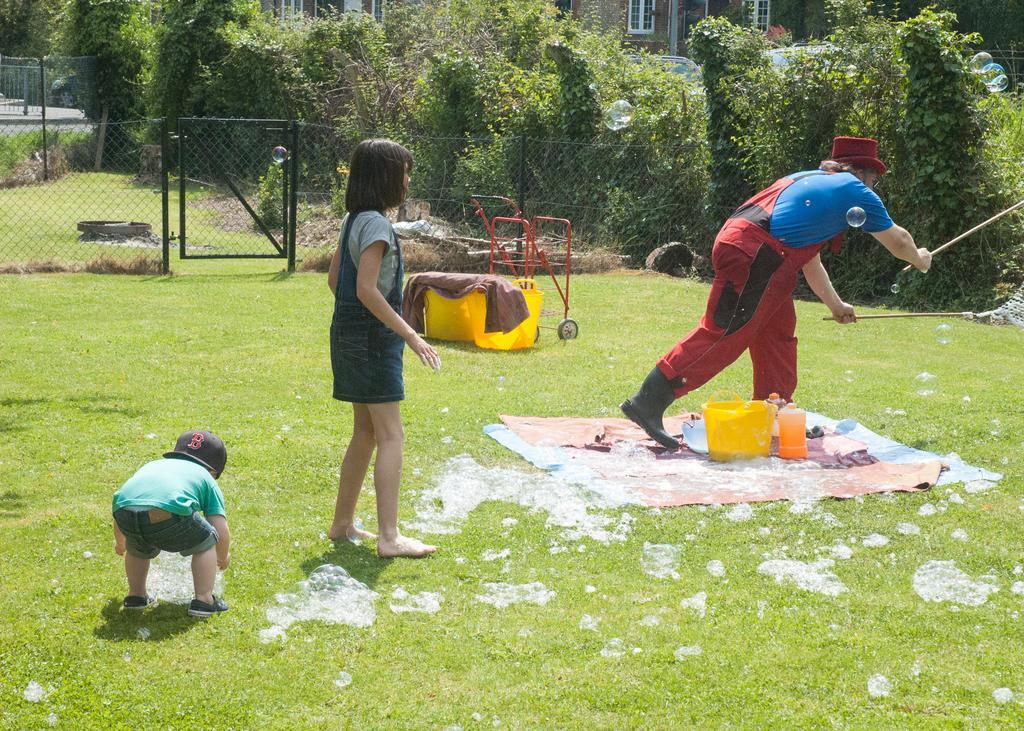How would you summarize this image in a sentence or two? In this image there are two people. In front of them there is another person standing on the mat. He is holding the sticks. Beside him there are a few objects. At the bottom of the image there is grass on the surface. In the center of the image there is a metal fence. In front of the fence there are a few objects. In the background of the image there are trees, buildings, cars. 